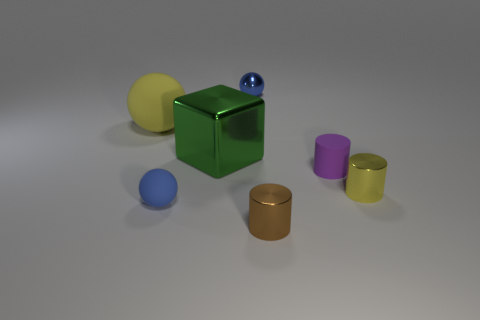Subtract all yellow shiny cylinders. How many cylinders are left? 2 Subtract all brown cylinders. How many cylinders are left? 2 Add 1 purple rubber things. How many objects exist? 8 Subtract all green cubes. How many blue balls are left? 2 Subtract 1 cubes. How many cubes are left? 0 Subtract all cubes. How many objects are left? 6 Subtract all red cylinders. Subtract all cyan blocks. How many cylinders are left? 3 Subtract all small gray matte objects. Subtract all tiny things. How many objects are left? 2 Add 6 yellow shiny cylinders. How many yellow shiny cylinders are left? 7 Add 2 big cyan things. How many big cyan things exist? 2 